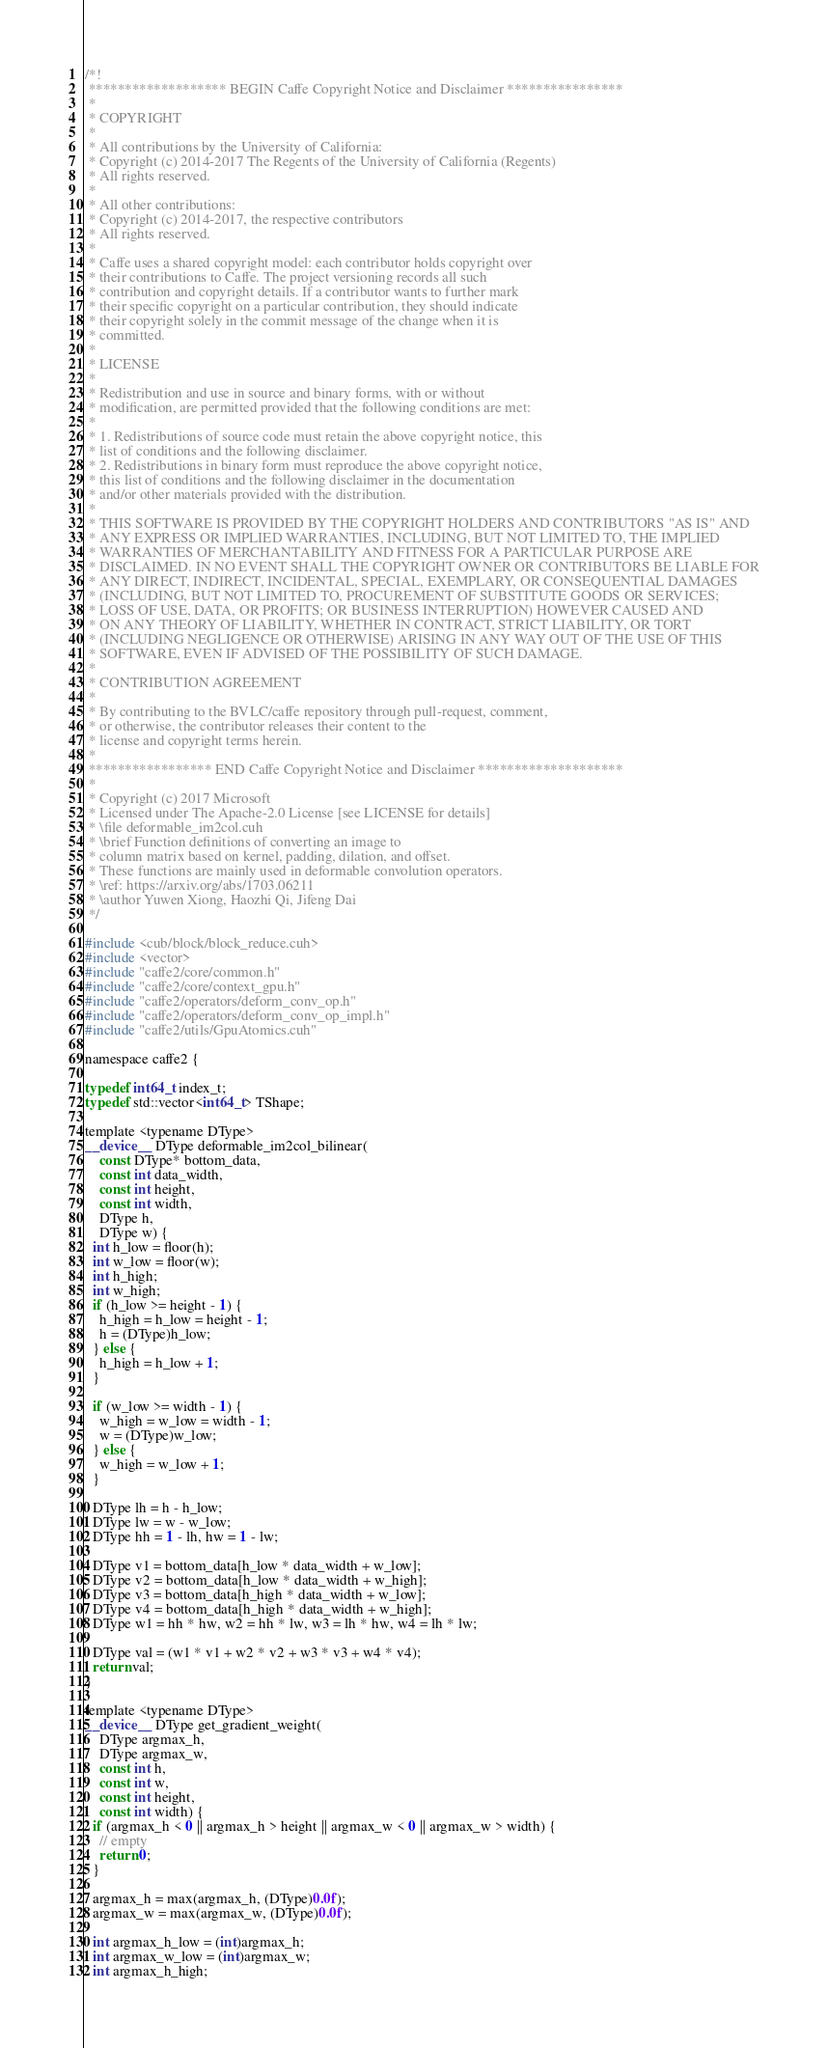Convert code to text. <code><loc_0><loc_0><loc_500><loc_500><_Cuda_>/*!
 ******************* BEGIN Caffe Copyright Notice and Disclaimer ****************
 *
 * COPYRIGHT
 *
 * All contributions by the University of California:
 * Copyright (c) 2014-2017 The Regents of the University of California (Regents)
 * All rights reserved.
 *
 * All other contributions:
 * Copyright (c) 2014-2017, the respective contributors
 * All rights reserved.
 *
 * Caffe uses a shared copyright model: each contributor holds copyright over
 * their contributions to Caffe. The project versioning records all such
 * contribution and copyright details. If a contributor wants to further mark
 * their specific copyright on a particular contribution, they should indicate
 * their copyright solely in the commit message of the change when it is
 * committed.
 *
 * LICENSE
 *
 * Redistribution and use in source and binary forms, with or without
 * modification, are permitted provided that the following conditions are met:
 *
 * 1. Redistributions of source code must retain the above copyright notice, this
 * list of conditions and the following disclaimer.
 * 2. Redistributions in binary form must reproduce the above copyright notice,
 * this list of conditions and the following disclaimer in the documentation
 * and/or other materials provided with the distribution.
 *
 * THIS SOFTWARE IS PROVIDED BY THE COPYRIGHT HOLDERS AND CONTRIBUTORS "AS IS" AND
 * ANY EXPRESS OR IMPLIED WARRANTIES, INCLUDING, BUT NOT LIMITED TO, THE IMPLIED
 * WARRANTIES OF MERCHANTABILITY AND FITNESS FOR A PARTICULAR PURPOSE ARE
 * DISCLAIMED. IN NO EVENT SHALL THE COPYRIGHT OWNER OR CONTRIBUTORS BE LIABLE FOR
 * ANY DIRECT, INDIRECT, INCIDENTAL, SPECIAL, EXEMPLARY, OR CONSEQUENTIAL DAMAGES
 * (INCLUDING, BUT NOT LIMITED TO, PROCUREMENT OF SUBSTITUTE GOODS OR SERVICES;
 * LOSS OF USE, DATA, OR PROFITS; OR BUSINESS INTERRUPTION) HOWEVER CAUSED AND
 * ON ANY THEORY OF LIABILITY, WHETHER IN CONTRACT, STRICT LIABILITY, OR TORT
 * (INCLUDING NEGLIGENCE OR OTHERWISE) ARISING IN ANY WAY OUT OF THE USE OF THIS
 * SOFTWARE, EVEN IF ADVISED OF THE POSSIBILITY OF SUCH DAMAGE.
 *
 * CONTRIBUTION AGREEMENT
 *
 * By contributing to the BVLC/caffe repository through pull-request, comment,
 * or otherwise, the contributor releases their content to the
 * license and copyright terms herein.
 *
 ***************** END Caffe Copyright Notice and Disclaimer ********************
 *
 * Copyright (c) 2017 Microsoft
 * Licensed under The Apache-2.0 License [see LICENSE for details]
 * \file deformable_im2col.cuh
 * \brief Function definitions of converting an image to
 * column matrix based on kernel, padding, dilation, and offset.
 * These functions are mainly used in deformable convolution operators.
 * \ref: https://arxiv.org/abs/1703.06211
 * \author Yuwen Xiong, Haozhi Qi, Jifeng Dai
 */

#include <cub/block/block_reduce.cuh>
#include <vector>
#include "caffe2/core/common.h"
#include "caffe2/core/context_gpu.h"
#include "caffe2/operators/deform_conv_op.h"
#include "caffe2/operators/deform_conv_op_impl.h"
#include "caffe2/utils/GpuAtomics.cuh"

namespace caffe2 {

typedef int64_t index_t;
typedef std::vector<int64_t> TShape;

template <typename DType>
__device__ DType deformable_im2col_bilinear(
    const DType* bottom_data,
    const int data_width,
    const int height,
    const int width,
    DType h,
    DType w) {
  int h_low = floor(h);
  int w_low = floor(w);
  int h_high;
  int w_high;
  if (h_low >= height - 1) {
    h_high = h_low = height - 1;
    h = (DType)h_low;
  } else {
    h_high = h_low + 1;
  }

  if (w_low >= width - 1) {
    w_high = w_low = width - 1;
    w = (DType)w_low;
  } else {
    w_high = w_low + 1;
  }

  DType lh = h - h_low;
  DType lw = w - w_low;
  DType hh = 1 - lh, hw = 1 - lw;

  DType v1 = bottom_data[h_low * data_width + w_low];
  DType v2 = bottom_data[h_low * data_width + w_high];
  DType v3 = bottom_data[h_high * data_width + w_low];
  DType v4 = bottom_data[h_high * data_width + w_high];
  DType w1 = hh * hw, w2 = hh * lw, w3 = lh * hw, w4 = lh * lw;

  DType val = (w1 * v1 + w2 * v2 + w3 * v3 + w4 * v4);
  return val;
}

template <typename DType>
__device__ DType get_gradient_weight(
    DType argmax_h,
    DType argmax_w,
    const int h,
    const int w,
    const int height,
    const int width) {
  if (argmax_h < 0 || argmax_h > height || argmax_w < 0 || argmax_w > width) {
    // empty
    return 0;
  }

  argmax_h = max(argmax_h, (DType)0.0f);
  argmax_w = max(argmax_w, (DType)0.0f);

  int argmax_h_low = (int)argmax_h;
  int argmax_w_low = (int)argmax_w;
  int argmax_h_high;</code> 